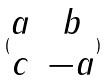Convert formula to latex. <formula><loc_0><loc_0><loc_500><loc_500>( \begin{matrix} a & b \\ c & - a \end{matrix} )</formula> 